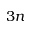<formula> <loc_0><loc_0><loc_500><loc_500>3 n</formula> 